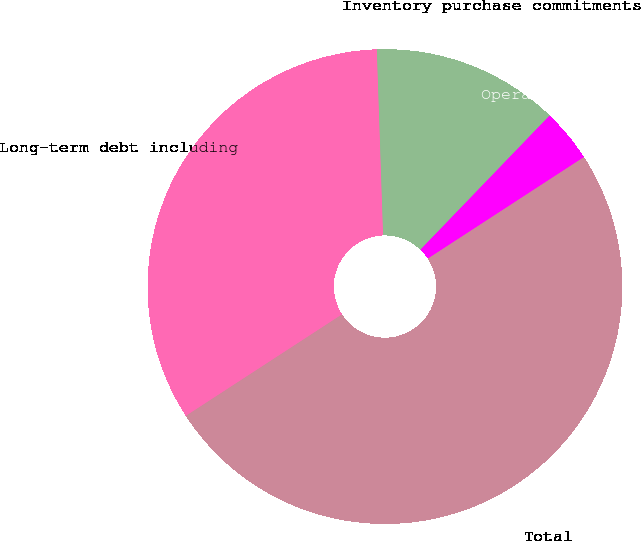<chart> <loc_0><loc_0><loc_500><loc_500><pie_chart><fcel>Long-term debt including<fcel>Inventory purchase commitments<fcel>Operating lease obligations<fcel>Total<nl><fcel>33.63%<fcel>12.74%<fcel>3.62%<fcel>50.0%<nl></chart> 